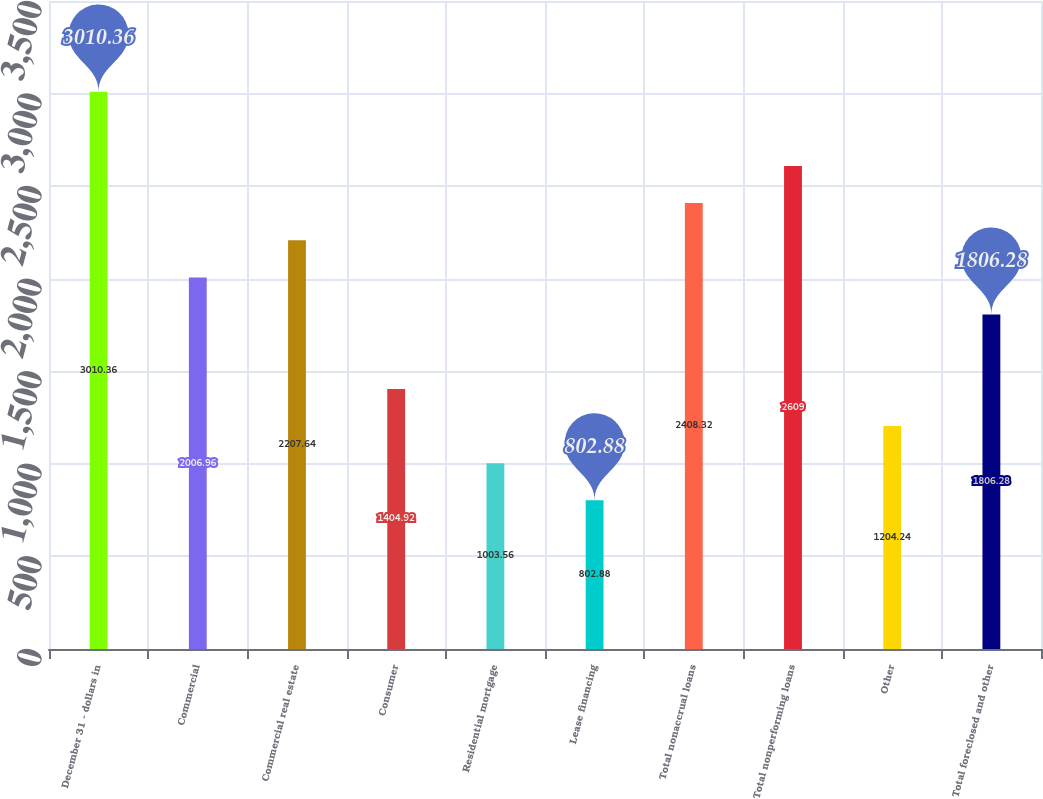Convert chart. <chart><loc_0><loc_0><loc_500><loc_500><bar_chart><fcel>December 31 - dollars in<fcel>Commercial<fcel>Commercial real estate<fcel>Consumer<fcel>Residential mortgage<fcel>Lease financing<fcel>Total nonaccrual loans<fcel>Total nonperforming loans<fcel>Other<fcel>Total foreclosed and other<nl><fcel>3010.36<fcel>2006.96<fcel>2207.64<fcel>1404.92<fcel>1003.56<fcel>802.88<fcel>2408.32<fcel>2609<fcel>1204.24<fcel>1806.28<nl></chart> 